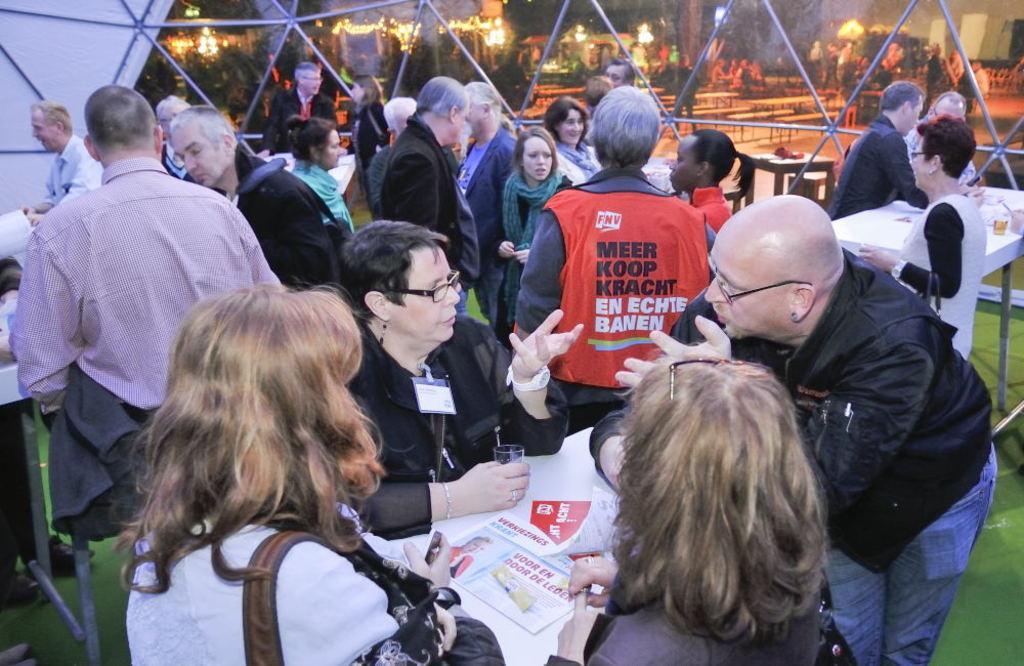How would you summarize this image in a sentence or two? This picture describe about the group of people in the hall discussing something. In front there is a table on which we can see newspaper. In the background there is a glass panel wall. 